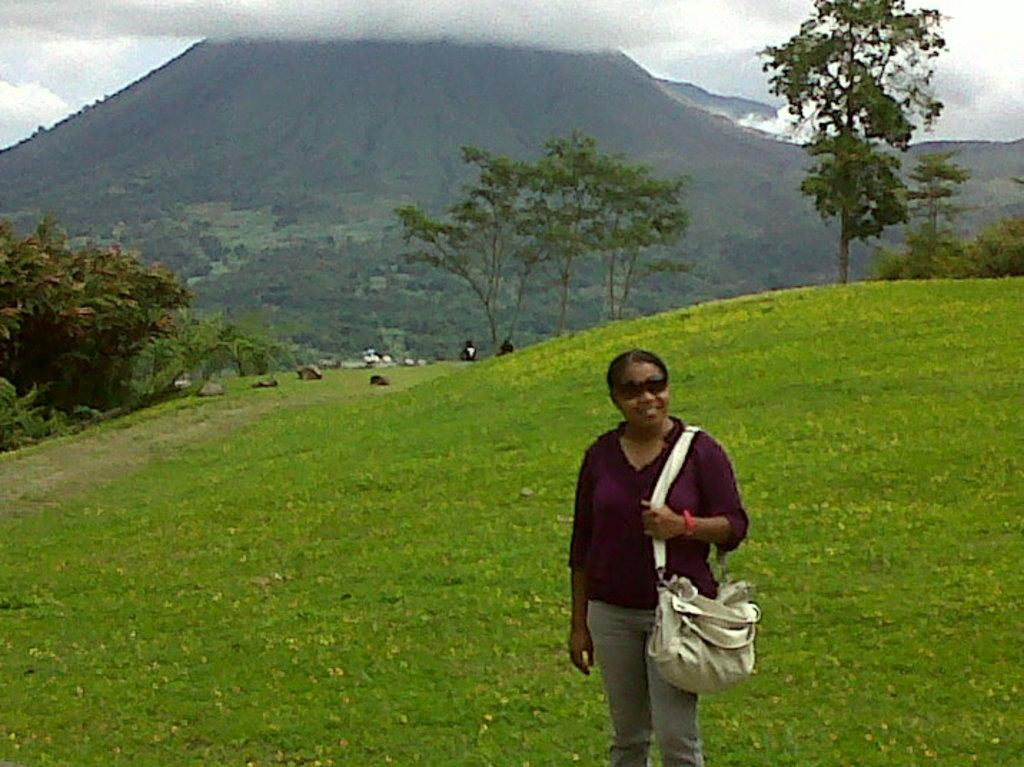Who is present in the image? There is a woman in the image. What is the woman wearing? The woman is wearing spectacles. What is the woman holding? The woman is holding a bag. What can be seen in the background of the image? There are rocks, trees, hills, and the sky visible in the background of the image. What type of lettuce is growing in the woman's yard in the image? There is no yard or lettuce present in the image. 